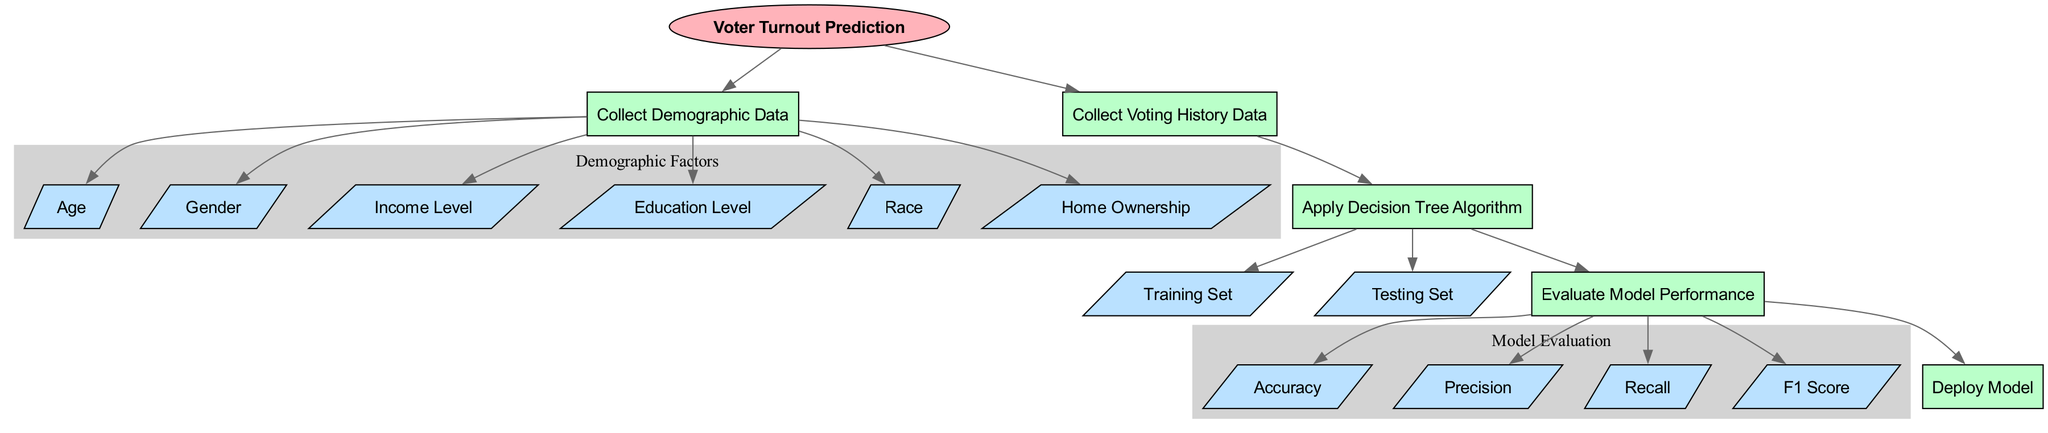What is the starting point of the diagram? The diagram begins with the "Voter Turnout Prediction" node, labeled as the starting point of the process.
Answer: Voter Turnout Prediction How many demographic factors are collected? There are six demographic factors represented in the diagram: Age, Gender, Income Level, Education Level, Race, and Home Ownership.
Answer: Six What is the purpose of node 10? Node 10 indicates the application of the Decision Tree Algorithm, which is a key step in predicting voter turnout based on collected data.
Answer: Apply Decision Tree Algorithm What follows after the "Evaluate Model Performance" process? After "Evaluate Model Performance," the diagram indicates deployment of the model as the next process, suggesting the workflow continues to use the evaluated model for predictions.
Answer: Deploy Model Which node represents the data used for training? The node labeled "Training Set" represents the data utilized for training the decision tree model in the prediction process.
Answer: Training Set How many performance metrics are evaluated? Four performance metrics are evaluated in the diagram: Accuracy, Precision, Recall, and F1 Score, which provide a comprehensive assessment of the model's performance.
Answer: Four What is the flow of the process after collecting demographic data? After "Collect Demographic Data," the process flows to "Collect Voting History Data" and then to the application of the decision tree algorithm indicating a sequential approach in the model-building process.
Answer: Collect Voting History Data What type of diagram is presented? The diagram is a Machine Learning Diagram specifically focused on predicting voter turnout using demographic factors and evaluating the model's performance.
Answer: Machine Learning Diagram 